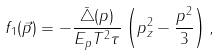Convert formula to latex. <formula><loc_0><loc_0><loc_500><loc_500>f _ { 1 } ( \vec { p } ) = - \frac { \bar { \triangle } ( p ) } { E _ { p } T ^ { 2 } \tau } \left ( p _ { z } ^ { 2 } - \frac { p ^ { 2 } } { 3 } \right ) ,</formula> 